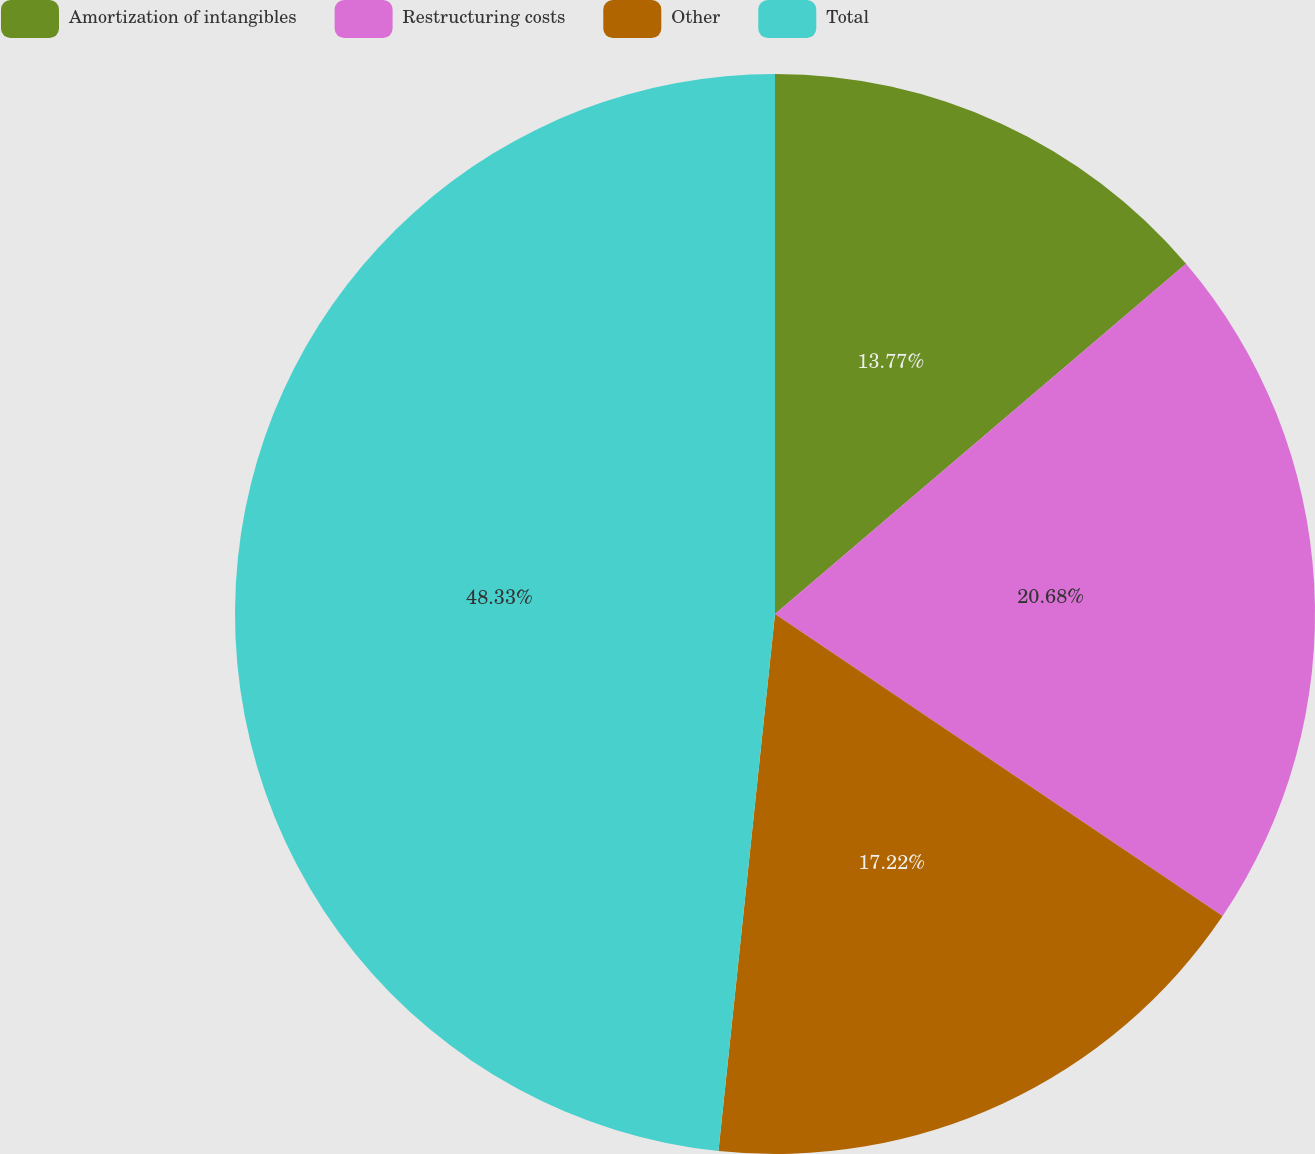Convert chart to OTSL. <chart><loc_0><loc_0><loc_500><loc_500><pie_chart><fcel>Amortization of intangibles<fcel>Restructuring costs<fcel>Other<fcel>Total<nl><fcel>13.77%<fcel>20.68%<fcel>17.22%<fcel>48.33%<nl></chart> 